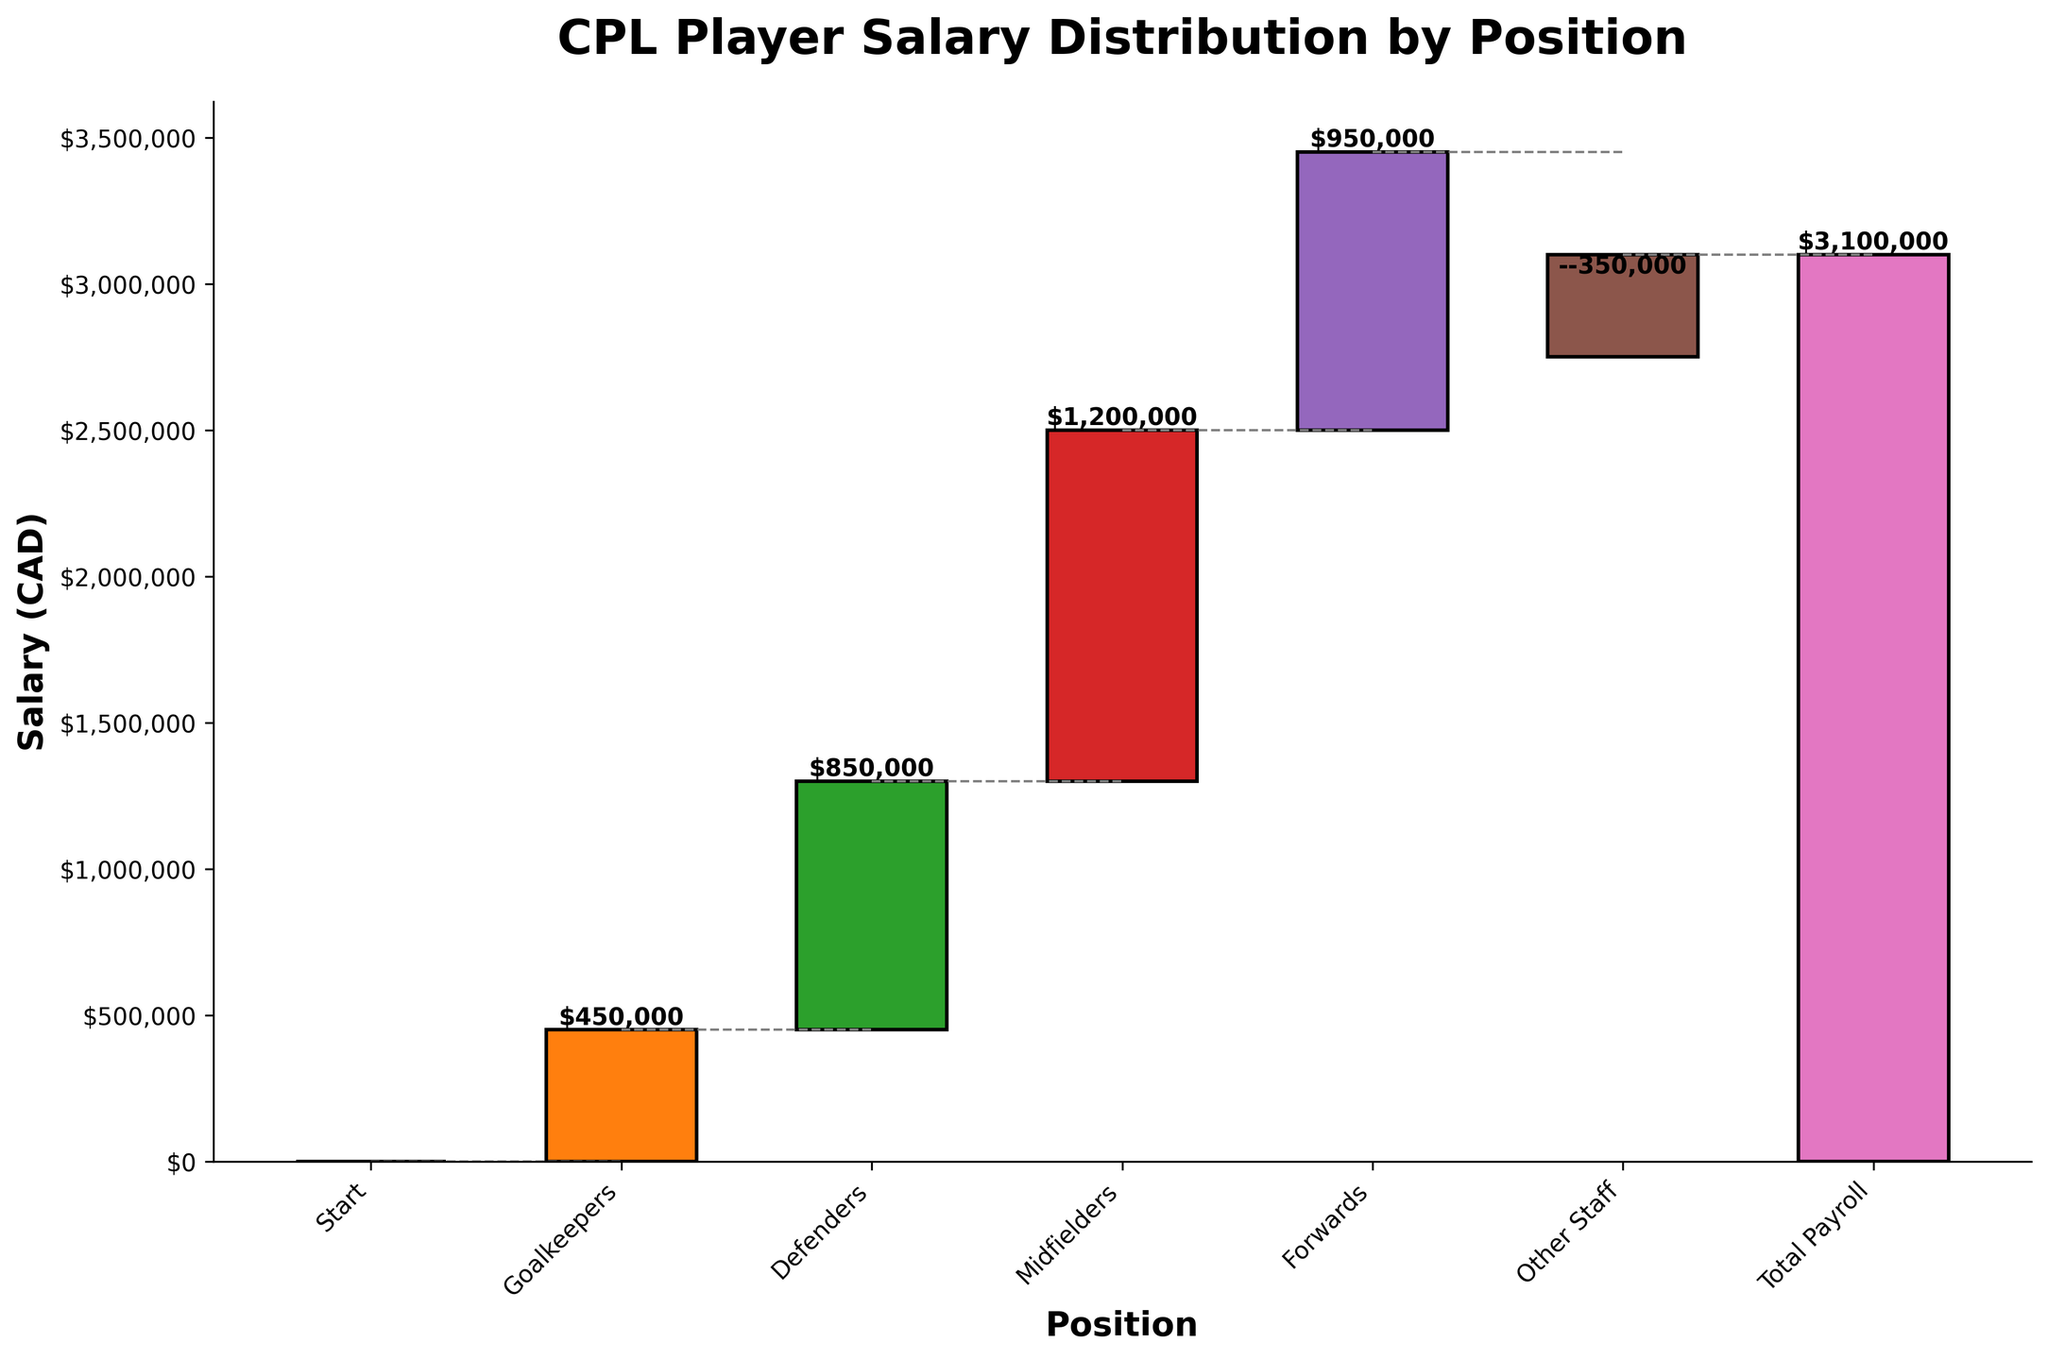What's the title of the chart? The title of the chart is displayed at the top. It reads "CPL Player Salary Distribution by Position".
Answer: CPL Player Salary Distribution by Position How much is the salary for Midfielders? Check the bar labeled "Midfielders" and read the value on the y-axis where the bar ends. The label on top of the bar also indicates the salary, which is $1,200,000.
Answer: $1,200,000 What is the total payroll? The final bar is labeled "Total Payroll". Read the value at the top of this bar. The label indicates $3,100,000.
Answer: $3,100,000 How much does the salary for Goalkeepers contribute to the total payroll? Look at the bar labeled "Goalkeepers" and read the salary value. The salary for Goalkeepers is $450,000.
Answer: $450,000 What is the cumulative amount after adding the Defenders' salary? Sum the salaries of the categories up to and including Defenders. The salaries are $0 (Start) + $450,000 (Goalkeepers) + $850,000 (Defenders), resulting in $1,300,000.
Answer: $1,300,000 Which position has the highest salary? Compare the heights of all the bars corresponding to positions (ignoring "Total Payroll" and "Other Staff"). The "Midfielders" bar is the tallest, indicating the highest salary.
Answer: Midfielders How much is contributed by the "Other Staff", and how does it affect the total payroll? Check the value for the "Other Staff" bar, which is -$350,000. This negative value is subtracted from the cumulative salary.
Answer: -$350,000 What is the cumulative salary amount just before the "Other Staff" contribution? The cumulative salary before "Other Staff" can be seen at the end of the "Forwards" bar, which is shown to be $3,450,000.
Answer: $3,450,000 How much higher is the Midfielders' salary compared to the Forwards'? Subtract the Forwards' salary from the Midfielders' salary: $1,200,000 (Midfielders) - $950,000 (Forwards) = $250,000.
Answer: $250,000 Which position shows a negative contribution to the salary distribution? Identify any bars with a negative value by looking at the labels inside them. The "Other Staff" bar is the only one with a negative value of -$350,000.
Answer: Other Staff 